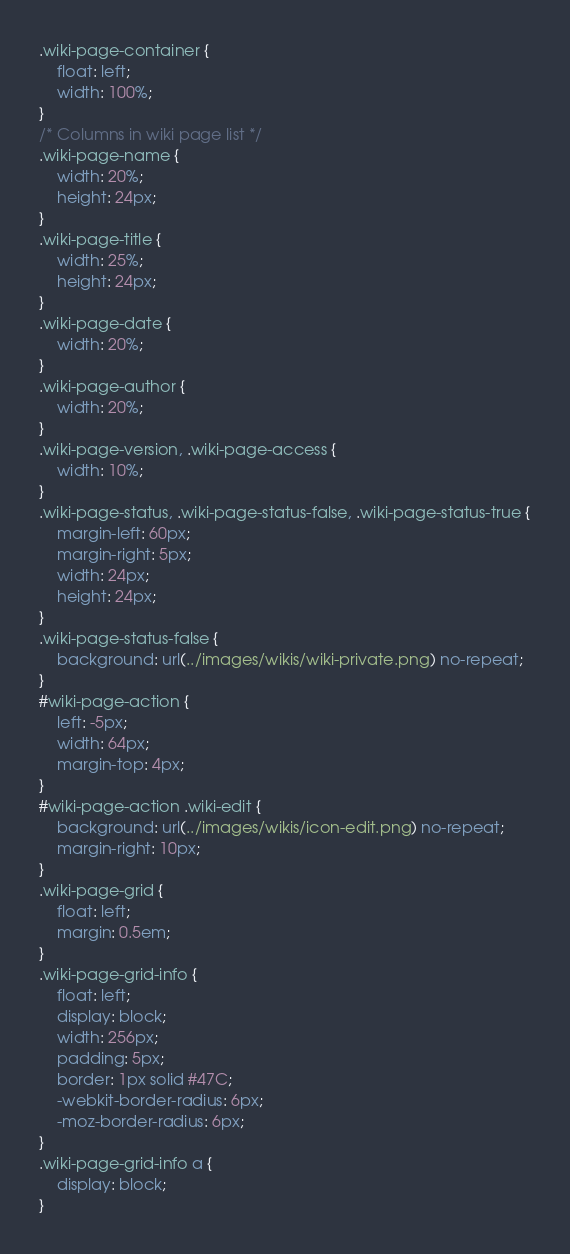Convert code to text. <code><loc_0><loc_0><loc_500><loc_500><_CSS_>.wiki-page-container {
    float: left;
    width: 100%;
}
/* Columns in wiki page list */
.wiki-page-name {
    width: 20%;
    height: 24px;
}
.wiki-page-title {
    width: 25%;
    height: 24px;
}
.wiki-page-date {
    width: 20%;
}
.wiki-page-author {
    width: 20%;
}
.wiki-page-version, .wiki-page-access {
    width: 10%;
}
.wiki-page-status, .wiki-page-status-false, .wiki-page-status-true {
    margin-left: 60px;
    margin-right: 5px;
    width: 24px;
    height: 24px;
}
.wiki-page-status-false {
    background: url(../images/wikis/wiki-private.png) no-repeat;
}
#wiki-page-action {
    left: -5px;
    width: 64px;
    margin-top: 4px;
}
#wiki-page-action .wiki-edit {
    background: url(../images/wikis/icon-edit.png) no-repeat;
    margin-right: 10px;
}
.wiki-page-grid {
    float: left;
    margin: 0.5em;
}
.wiki-page-grid-info {
    float: left;
    display: block;
    width: 256px;
    padding: 5px;
    border: 1px solid #47C;
    -webkit-border-radius: 6px;
    -moz-border-radius: 6px;
}
.wiki-page-grid-info a {
    display: block;
}</code> 